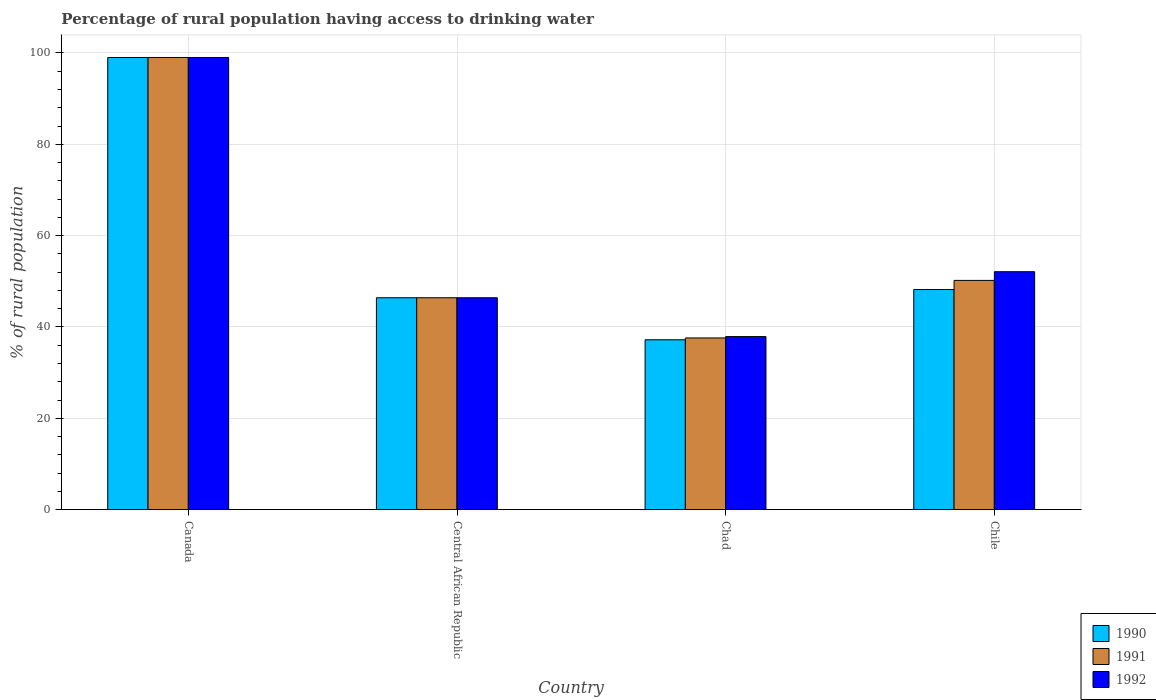How many bars are there on the 1st tick from the left?
Your answer should be very brief. 3. What is the label of the 1st group of bars from the left?
Ensure brevity in your answer.  Canada. What is the percentage of rural population having access to drinking water in 1991 in Chile?
Offer a very short reply. 50.2. Across all countries, what is the minimum percentage of rural population having access to drinking water in 1991?
Ensure brevity in your answer.  37.6. In which country was the percentage of rural population having access to drinking water in 1992 minimum?
Keep it short and to the point. Chad. What is the total percentage of rural population having access to drinking water in 1992 in the graph?
Offer a very short reply. 235.4. What is the difference between the percentage of rural population having access to drinking water in 1992 in Central African Republic and that in Chile?
Provide a succinct answer. -5.7. What is the difference between the percentage of rural population having access to drinking water in 1990 in Chad and the percentage of rural population having access to drinking water in 1992 in Central African Republic?
Provide a short and direct response. -9.2. What is the average percentage of rural population having access to drinking water in 1992 per country?
Your response must be concise. 58.85. What is the difference between the percentage of rural population having access to drinking water of/in 1992 and percentage of rural population having access to drinking water of/in 1991 in Chad?
Offer a very short reply. 0.3. What is the ratio of the percentage of rural population having access to drinking water in 1990 in Chad to that in Chile?
Ensure brevity in your answer.  0.77. Is the difference between the percentage of rural population having access to drinking water in 1992 in Central African Republic and Chad greater than the difference between the percentage of rural population having access to drinking water in 1991 in Central African Republic and Chad?
Your answer should be very brief. No. What is the difference between the highest and the second highest percentage of rural population having access to drinking water in 1990?
Your answer should be very brief. -50.8. What is the difference between the highest and the lowest percentage of rural population having access to drinking water in 1990?
Provide a succinct answer. 61.8. In how many countries, is the percentage of rural population having access to drinking water in 1991 greater than the average percentage of rural population having access to drinking water in 1991 taken over all countries?
Provide a short and direct response. 1. Is the sum of the percentage of rural population having access to drinking water in 1992 in Canada and Chile greater than the maximum percentage of rural population having access to drinking water in 1991 across all countries?
Keep it short and to the point. Yes. How many countries are there in the graph?
Ensure brevity in your answer.  4. What is the difference between two consecutive major ticks on the Y-axis?
Keep it short and to the point. 20. Are the values on the major ticks of Y-axis written in scientific E-notation?
Make the answer very short. No. Does the graph contain any zero values?
Ensure brevity in your answer.  No. Where does the legend appear in the graph?
Your answer should be compact. Bottom right. How are the legend labels stacked?
Provide a succinct answer. Vertical. What is the title of the graph?
Your response must be concise. Percentage of rural population having access to drinking water. Does "1980" appear as one of the legend labels in the graph?
Offer a terse response. No. What is the label or title of the Y-axis?
Keep it short and to the point. % of rural population. What is the % of rural population of 1992 in Canada?
Your response must be concise. 99. What is the % of rural population of 1990 in Central African Republic?
Offer a very short reply. 46.4. What is the % of rural population in 1991 in Central African Republic?
Your answer should be compact. 46.4. What is the % of rural population of 1992 in Central African Republic?
Your response must be concise. 46.4. What is the % of rural population in 1990 in Chad?
Your answer should be very brief. 37.2. What is the % of rural population in 1991 in Chad?
Your answer should be compact. 37.6. What is the % of rural population of 1992 in Chad?
Offer a very short reply. 37.9. What is the % of rural population of 1990 in Chile?
Your answer should be compact. 48.2. What is the % of rural population in 1991 in Chile?
Provide a short and direct response. 50.2. What is the % of rural population in 1992 in Chile?
Give a very brief answer. 52.1. Across all countries, what is the maximum % of rural population in 1990?
Your answer should be very brief. 99. Across all countries, what is the maximum % of rural population in 1991?
Ensure brevity in your answer.  99. Across all countries, what is the maximum % of rural population of 1992?
Keep it short and to the point. 99. Across all countries, what is the minimum % of rural population of 1990?
Your answer should be very brief. 37.2. Across all countries, what is the minimum % of rural population of 1991?
Offer a very short reply. 37.6. Across all countries, what is the minimum % of rural population of 1992?
Ensure brevity in your answer.  37.9. What is the total % of rural population of 1990 in the graph?
Provide a short and direct response. 230.8. What is the total % of rural population of 1991 in the graph?
Provide a succinct answer. 233.2. What is the total % of rural population of 1992 in the graph?
Give a very brief answer. 235.4. What is the difference between the % of rural population in 1990 in Canada and that in Central African Republic?
Keep it short and to the point. 52.6. What is the difference between the % of rural population in 1991 in Canada and that in Central African Republic?
Your response must be concise. 52.6. What is the difference between the % of rural population of 1992 in Canada and that in Central African Republic?
Your answer should be very brief. 52.6. What is the difference between the % of rural population of 1990 in Canada and that in Chad?
Provide a succinct answer. 61.8. What is the difference between the % of rural population of 1991 in Canada and that in Chad?
Provide a short and direct response. 61.4. What is the difference between the % of rural population of 1992 in Canada and that in Chad?
Keep it short and to the point. 61.1. What is the difference between the % of rural population in 1990 in Canada and that in Chile?
Give a very brief answer. 50.8. What is the difference between the % of rural population in 1991 in Canada and that in Chile?
Provide a short and direct response. 48.8. What is the difference between the % of rural population in 1992 in Canada and that in Chile?
Your answer should be compact. 46.9. What is the difference between the % of rural population in 1991 in Central African Republic and that in Chad?
Your answer should be very brief. 8.8. What is the difference between the % of rural population of 1992 in Central African Republic and that in Chad?
Provide a short and direct response. 8.5. What is the difference between the % of rural population in 1990 in Central African Republic and that in Chile?
Offer a terse response. -1.8. What is the difference between the % of rural population of 1992 in Central African Republic and that in Chile?
Your answer should be very brief. -5.7. What is the difference between the % of rural population in 1990 in Canada and the % of rural population in 1991 in Central African Republic?
Offer a terse response. 52.6. What is the difference between the % of rural population of 1990 in Canada and the % of rural population of 1992 in Central African Republic?
Your answer should be very brief. 52.6. What is the difference between the % of rural population in 1991 in Canada and the % of rural population in 1992 in Central African Republic?
Your answer should be compact. 52.6. What is the difference between the % of rural population in 1990 in Canada and the % of rural population in 1991 in Chad?
Provide a succinct answer. 61.4. What is the difference between the % of rural population of 1990 in Canada and the % of rural population of 1992 in Chad?
Your answer should be very brief. 61.1. What is the difference between the % of rural population in 1991 in Canada and the % of rural population in 1992 in Chad?
Your answer should be very brief. 61.1. What is the difference between the % of rural population in 1990 in Canada and the % of rural population in 1991 in Chile?
Offer a terse response. 48.8. What is the difference between the % of rural population in 1990 in Canada and the % of rural population in 1992 in Chile?
Give a very brief answer. 46.9. What is the difference between the % of rural population in 1991 in Canada and the % of rural population in 1992 in Chile?
Give a very brief answer. 46.9. What is the difference between the % of rural population of 1990 in Central African Republic and the % of rural population of 1992 in Chad?
Ensure brevity in your answer.  8.5. What is the difference between the % of rural population of 1991 in Central African Republic and the % of rural population of 1992 in Chad?
Keep it short and to the point. 8.5. What is the difference between the % of rural population of 1990 in Central African Republic and the % of rural population of 1992 in Chile?
Give a very brief answer. -5.7. What is the difference between the % of rural population in 1991 in Central African Republic and the % of rural population in 1992 in Chile?
Make the answer very short. -5.7. What is the difference between the % of rural population of 1990 in Chad and the % of rural population of 1991 in Chile?
Your answer should be very brief. -13. What is the difference between the % of rural population of 1990 in Chad and the % of rural population of 1992 in Chile?
Your response must be concise. -14.9. What is the difference between the % of rural population in 1991 in Chad and the % of rural population in 1992 in Chile?
Provide a succinct answer. -14.5. What is the average % of rural population of 1990 per country?
Provide a succinct answer. 57.7. What is the average % of rural population of 1991 per country?
Make the answer very short. 58.3. What is the average % of rural population in 1992 per country?
Make the answer very short. 58.85. What is the difference between the % of rural population of 1990 and % of rural population of 1992 in Canada?
Give a very brief answer. 0. What is the difference between the % of rural population of 1991 and % of rural population of 1992 in Central African Republic?
Your answer should be compact. 0. What is the difference between the % of rural population in 1990 and % of rural population in 1992 in Chad?
Ensure brevity in your answer.  -0.7. What is the ratio of the % of rural population in 1990 in Canada to that in Central African Republic?
Your answer should be compact. 2.13. What is the ratio of the % of rural population in 1991 in Canada to that in Central African Republic?
Make the answer very short. 2.13. What is the ratio of the % of rural population in 1992 in Canada to that in Central African Republic?
Your answer should be very brief. 2.13. What is the ratio of the % of rural population in 1990 in Canada to that in Chad?
Make the answer very short. 2.66. What is the ratio of the % of rural population in 1991 in Canada to that in Chad?
Keep it short and to the point. 2.63. What is the ratio of the % of rural population in 1992 in Canada to that in Chad?
Provide a succinct answer. 2.61. What is the ratio of the % of rural population of 1990 in Canada to that in Chile?
Your answer should be very brief. 2.05. What is the ratio of the % of rural population of 1991 in Canada to that in Chile?
Provide a short and direct response. 1.97. What is the ratio of the % of rural population in 1992 in Canada to that in Chile?
Offer a terse response. 1.9. What is the ratio of the % of rural population in 1990 in Central African Republic to that in Chad?
Provide a short and direct response. 1.25. What is the ratio of the % of rural population in 1991 in Central African Republic to that in Chad?
Provide a succinct answer. 1.23. What is the ratio of the % of rural population in 1992 in Central African Republic to that in Chad?
Provide a succinct answer. 1.22. What is the ratio of the % of rural population of 1990 in Central African Republic to that in Chile?
Your answer should be compact. 0.96. What is the ratio of the % of rural population in 1991 in Central African Republic to that in Chile?
Your response must be concise. 0.92. What is the ratio of the % of rural population of 1992 in Central African Republic to that in Chile?
Your answer should be compact. 0.89. What is the ratio of the % of rural population in 1990 in Chad to that in Chile?
Provide a short and direct response. 0.77. What is the ratio of the % of rural population in 1991 in Chad to that in Chile?
Your response must be concise. 0.75. What is the ratio of the % of rural population in 1992 in Chad to that in Chile?
Keep it short and to the point. 0.73. What is the difference between the highest and the second highest % of rural population of 1990?
Provide a succinct answer. 50.8. What is the difference between the highest and the second highest % of rural population in 1991?
Ensure brevity in your answer.  48.8. What is the difference between the highest and the second highest % of rural population of 1992?
Make the answer very short. 46.9. What is the difference between the highest and the lowest % of rural population of 1990?
Your answer should be very brief. 61.8. What is the difference between the highest and the lowest % of rural population in 1991?
Your response must be concise. 61.4. What is the difference between the highest and the lowest % of rural population of 1992?
Provide a succinct answer. 61.1. 